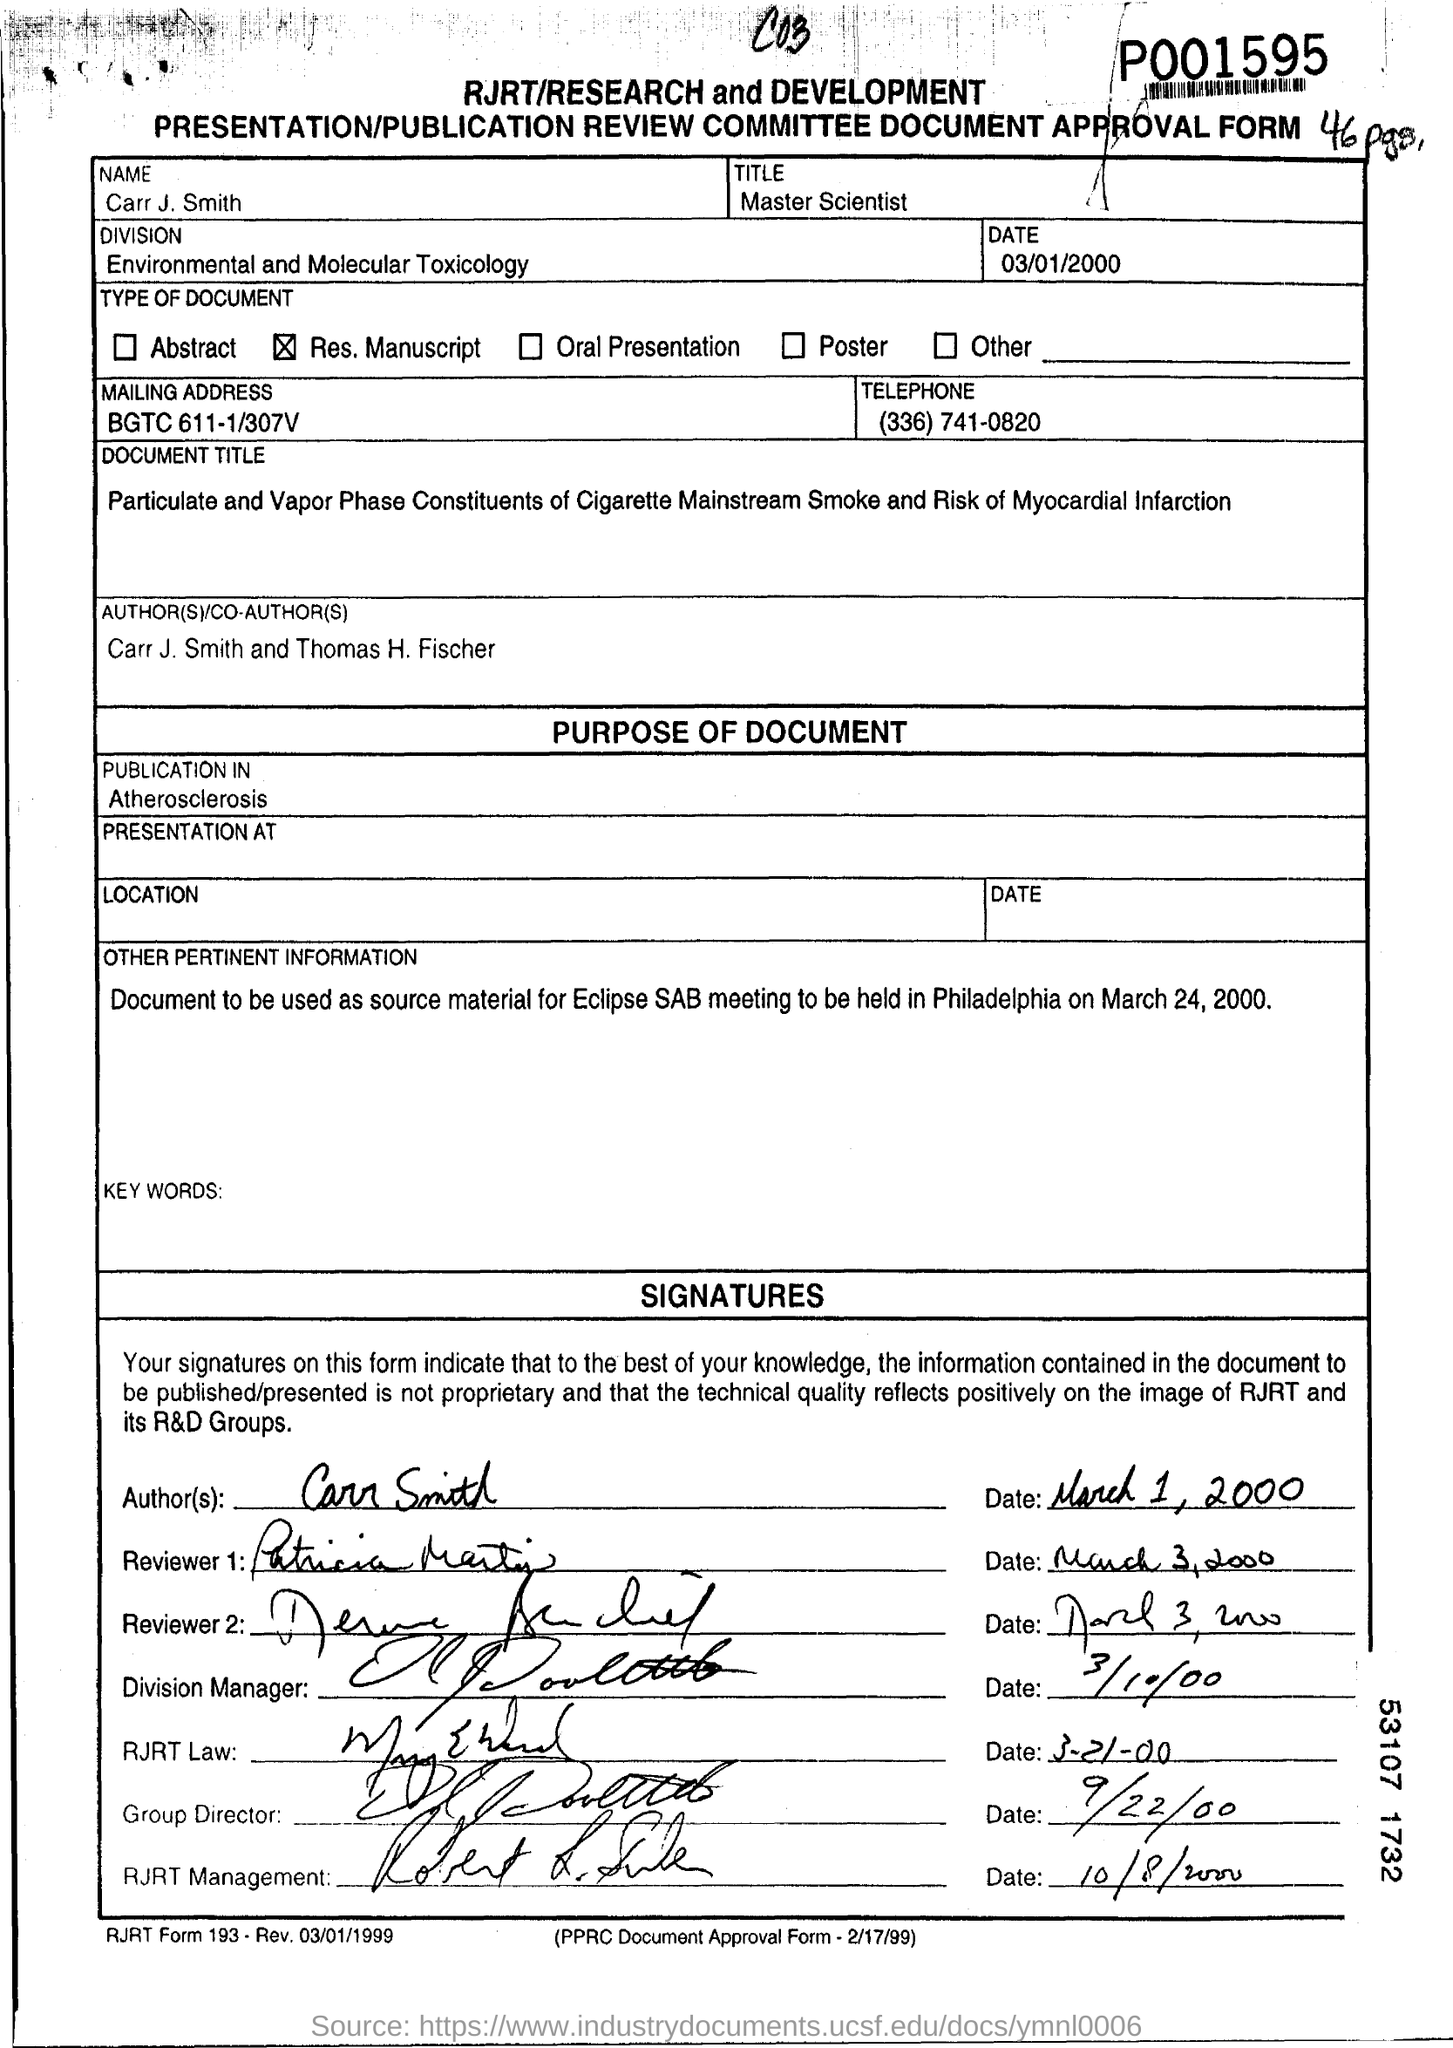Outline some significant characteristics in this image. The name mentioned on the publication review committee document approval from number 46 is Carr. J. Smith. The title mentioned in the form for Carr J. Smith is "Master Scientist. The publication review committee document approval number 46 mentions the division of Environmental and Molecular Toxicology. The telephone number mentioned in the form is (336) 741-0820. 